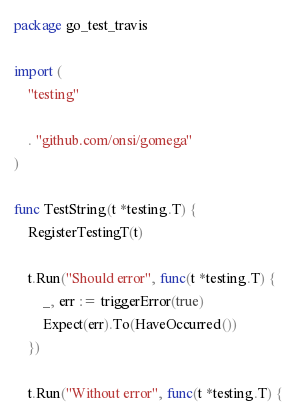Convert code to text. <code><loc_0><loc_0><loc_500><loc_500><_Go_>package go_test_travis

import (
	"testing"

	. "github.com/onsi/gomega"
)

func TestString(t *testing.T) {
	RegisterTestingT(t)

	t.Run("Should error", func(t *testing.T) {
		_, err := triggerError(true)
		Expect(err).To(HaveOccurred())
	})

	t.Run("Without error", func(t *testing.T) {</code> 